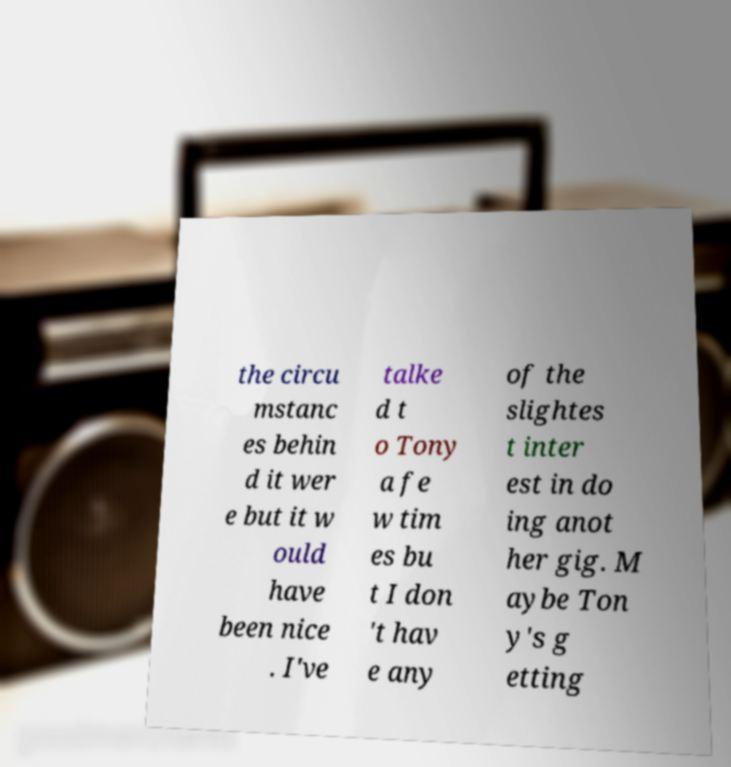Can you read and provide the text displayed in the image?This photo seems to have some interesting text. Can you extract and type it out for me? the circu mstanc es behin d it wer e but it w ould have been nice . I've talke d t o Tony a fe w tim es bu t I don 't hav e any of the slightes t inter est in do ing anot her gig. M aybe Ton y's g etting 